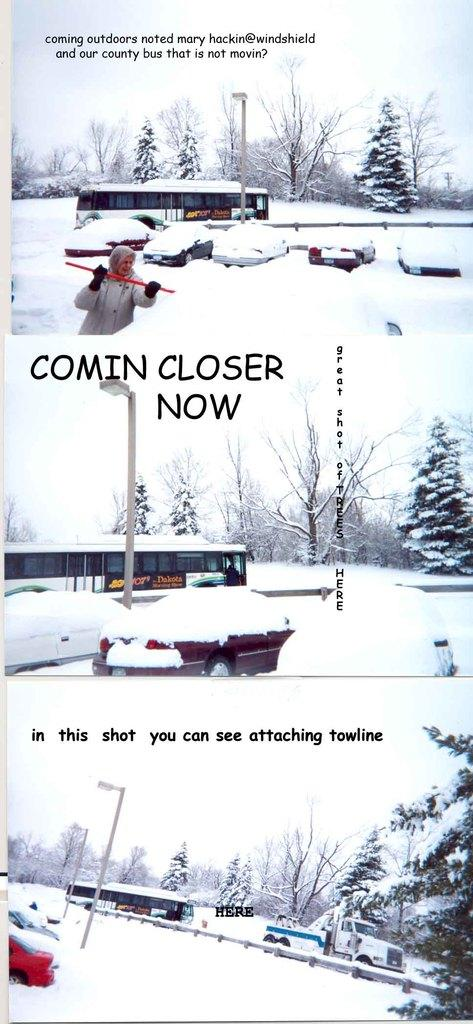What type of artwork is the image? The image is a collage. What is the condition of the ground in the image? The ground is covered with snow. What type of vehicles can be seen in the image? There are motor vehicles in the image. What type of natural elements are present in the image? There are trees in the image. What is the woman holding in her hand? The woman is holding a shovel in her hand. What type of structure is present in the image? There is a street pole in the image. What type of lighting is present in the image? There is a street light in the image. What type of barriers are present in the image? There are barriers in the image. What part of the environment is visible in the image? The sky is visible in the image. What type of fork is the woman using to grip the shovel in the image? There is no fork present in the image, and the woman is not using any tool to grip the shovel. What type of carpentry work is the woman performing in the image? There is no carpentry work being performed in the image, as the woman is holding a shovel, not a carpentry tool. 